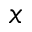<formula> <loc_0><loc_0><loc_500><loc_500>x</formula> 